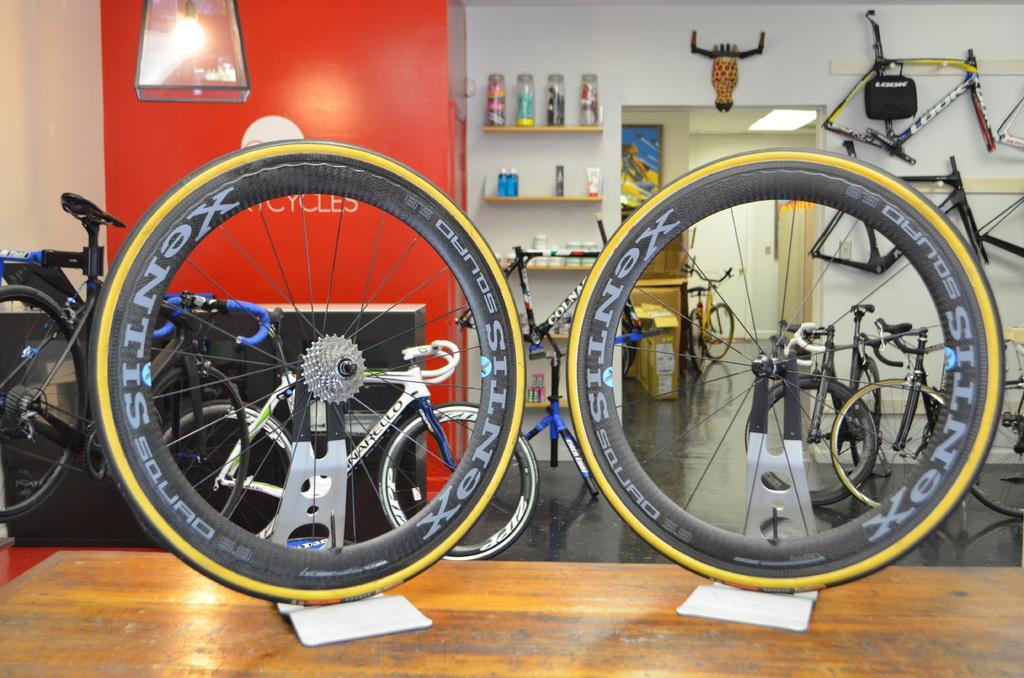How would you summarize this image in a sentence or two? In this image in the middle, there is a table on that there are tires. In the background there are many bicycles, tires, cycle parts, bottles, shelves, light, door and wall. 